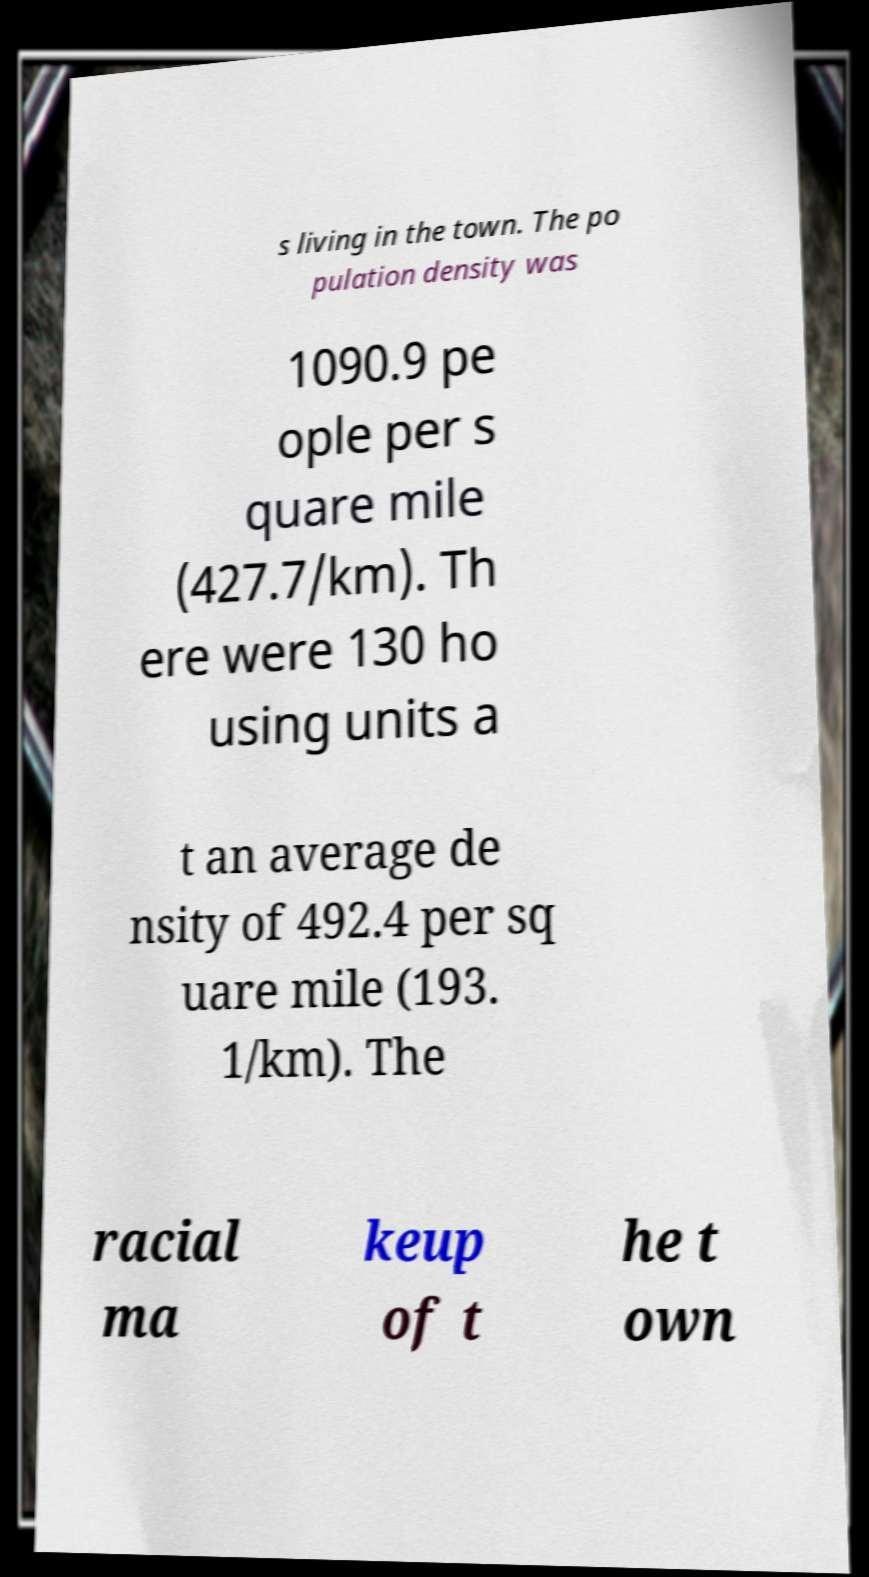What messages or text are displayed in this image? I need them in a readable, typed format. s living in the town. The po pulation density was 1090.9 pe ople per s quare mile (427.7/km). Th ere were 130 ho using units a t an average de nsity of 492.4 per sq uare mile (193. 1/km). The racial ma keup of t he t own 